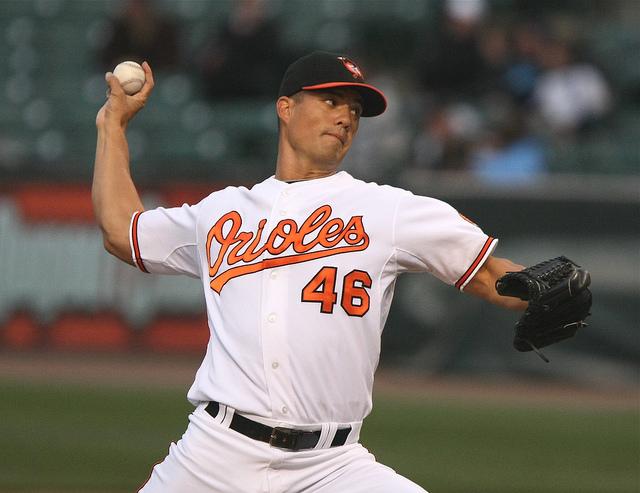What is the number on his uniform?
Be succinct. 46. What team is the man on?
Concise answer only. Orioles. What is the item on the man's hand called?
Be succinct. Glove. What is the man doing?
Concise answer only. Pitching. 